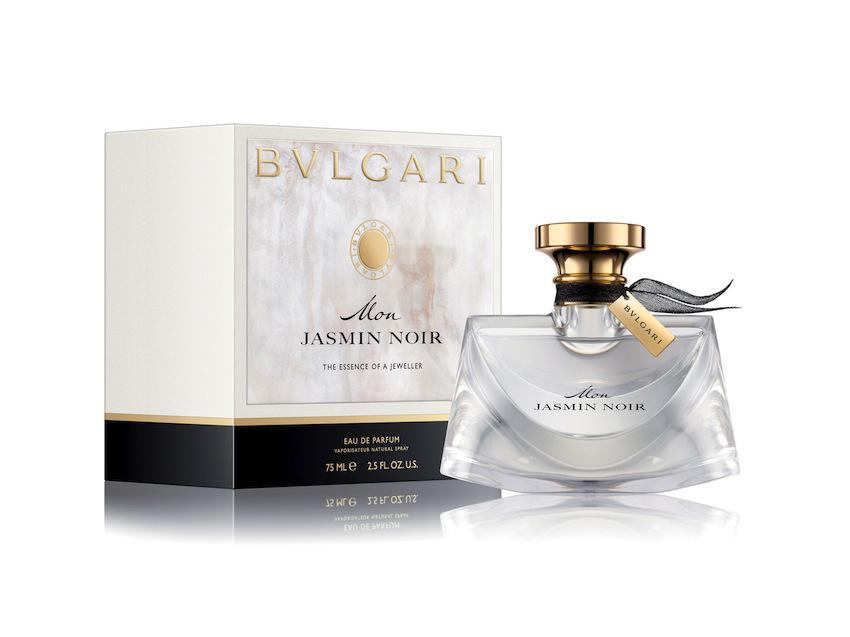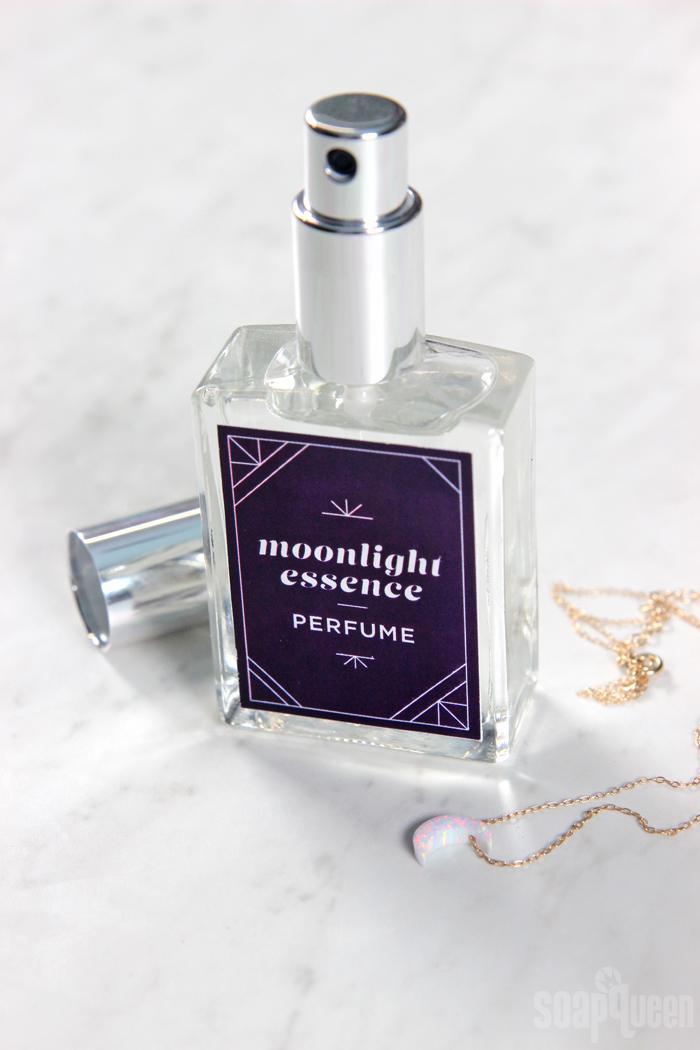The first image is the image on the left, the second image is the image on the right. Considering the images on both sides, is "A perfume bottle is uncapped." valid? Answer yes or no. Yes. 